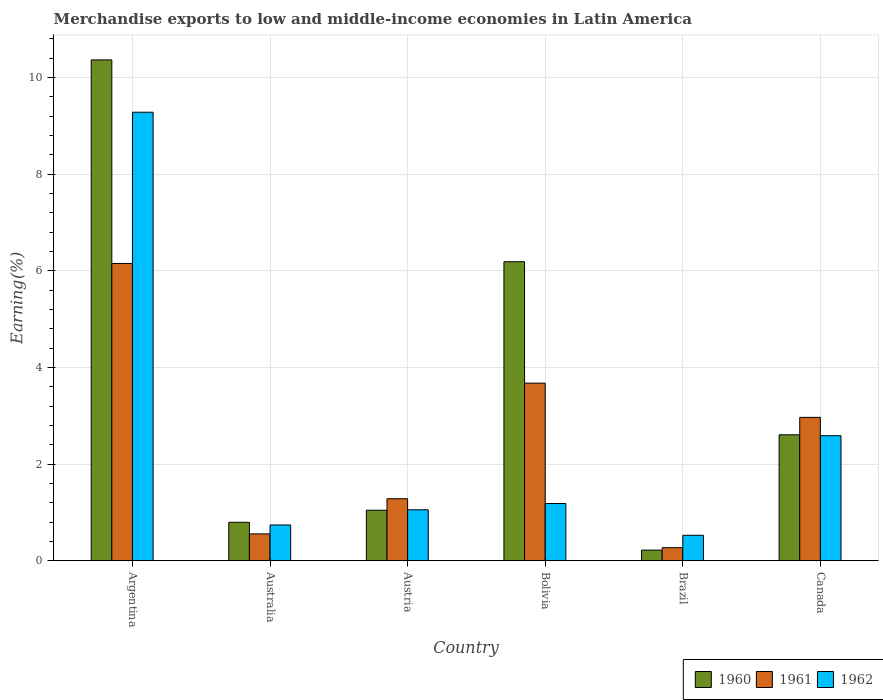How many different coloured bars are there?
Give a very brief answer. 3. What is the percentage of amount earned from merchandise exports in 1962 in Bolivia?
Your answer should be compact. 1.18. Across all countries, what is the maximum percentage of amount earned from merchandise exports in 1960?
Your answer should be very brief. 10.36. Across all countries, what is the minimum percentage of amount earned from merchandise exports in 1962?
Make the answer very short. 0.53. What is the total percentage of amount earned from merchandise exports in 1960 in the graph?
Offer a terse response. 21.21. What is the difference between the percentage of amount earned from merchandise exports in 1961 in Australia and that in Brazil?
Ensure brevity in your answer.  0.28. What is the difference between the percentage of amount earned from merchandise exports in 1961 in Canada and the percentage of amount earned from merchandise exports in 1960 in Austria?
Make the answer very short. 1.92. What is the average percentage of amount earned from merchandise exports in 1962 per country?
Your response must be concise. 2.56. What is the difference between the percentage of amount earned from merchandise exports of/in 1960 and percentage of amount earned from merchandise exports of/in 1962 in Australia?
Your response must be concise. 0.06. In how many countries, is the percentage of amount earned from merchandise exports in 1961 greater than 5.2 %?
Your answer should be compact. 1. What is the ratio of the percentage of amount earned from merchandise exports in 1961 in Austria to that in Brazil?
Give a very brief answer. 4.74. Is the percentage of amount earned from merchandise exports in 1961 in Austria less than that in Bolivia?
Your answer should be compact. Yes. What is the difference between the highest and the second highest percentage of amount earned from merchandise exports in 1961?
Your answer should be very brief. -0.71. What is the difference between the highest and the lowest percentage of amount earned from merchandise exports in 1962?
Provide a short and direct response. 8.75. How many bars are there?
Provide a succinct answer. 18. Does the graph contain grids?
Offer a very short reply. Yes. What is the title of the graph?
Provide a short and direct response. Merchandise exports to low and middle-income economies in Latin America. Does "1964" appear as one of the legend labels in the graph?
Provide a short and direct response. No. What is the label or title of the X-axis?
Your response must be concise. Country. What is the label or title of the Y-axis?
Your response must be concise. Earning(%). What is the Earning(%) of 1960 in Argentina?
Your response must be concise. 10.36. What is the Earning(%) of 1961 in Argentina?
Make the answer very short. 6.15. What is the Earning(%) in 1962 in Argentina?
Your response must be concise. 9.28. What is the Earning(%) of 1960 in Australia?
Give a very brief answer. 0.8. What is the Earning(%) in 1961 in Australia?
Ensure brevity in your answer.  0.56. What is the Earning(%) in 1962 in Australia?
Your answer should be very brief. 0.74. What is the Earning(%) in 1960 in Austria?
Your response must be concise. 1.05. What is the Earning(%) of 1961 in Austria?
Provide a succinct answer. 1.28. What is the Earning(%) in 1962 in Austria?
Give a very brief answer. 1.05. What is the Earning(%) of 1960 in Bolivia?
Keep it short and to the point. 6.19. What is the Earning(%) of 1961 in Bolivia?
Provide a short and direct response. 3.67. What is the Earning(%) of 1962 in Bolivia?
Provide a short and direct response. 1.18. What is the Earning(%) of 1960 in Brazil?
Your response must be concise. 0.22. What is the Earning(%) in 1961 in Brazil?
Give a very brief answer. 0.27. What is the Earning(%) of 1962 in Brazil?
Offer a very short reply. 0.53. What is the Earning(%) in 1960 in Canada?
Your response must be concise. 2.61. What is the Earning(%) of 1961 in Canada?
Provide a succinct answer. 2.97. What is the Earning(%) in 1962 in Canada?
Provide a succinct answer. 2.59. Across all countries, what is the maximum Earning(%) in 1960?
Keep it short and to the point. 10.36. Across all countries, what is the maximum Earning(%) in 1961?
Offer a very short reply. 6.15. Across all countries, what is the maximum Earning(%) of 1962?
Offer a terse response. 9.28. Across all countries, what is the minimum Earning(%) of 1960?
Your answer should be compact. 0.22. Across all countries, what is the minimum Earning(%) of 1961?
Provide a short and direct response. 0.27. Across all countries, what is the minimum Earning(%) in 1962?
Provide a short and direct response. 0.53. What is the total Earning(%) in 1960 in the graph?
Your answer should be compact. 21.21. What is the total Earning(%) of 1961 in the graph?
Your answer should be very brief. 14.9. What is the total Earning(%) of 1962 in the graph?
Keep it short and to the point. 15.37. What is the difference between the Earning(%) of 1960 in Argentina and that in Australia?
Give a very brief answer. 9.56. What is the difference between the Earning(%) of 1961 in Argentina and that in Australia?
Your response must be concise. 5.59. What is the difference between the Earning(%) of 1962 in Argentina and that in Australia?
Ensure brevity in your answer.  8.54. What is the difference between the Earning(%) of 1960 in Argentina and that in Austria?
Offer a very short reply. 9.31. What is the difference between the Earning(%) of 1961 in Argentina and that in Austria?
Keep it short and to the point. 4.87. What is the difference between the Earning(%) in 1962 in Argentina and that in Austria?
Your answer should be very brief. 8.22. What is the difference between the Earning(%) in 1960 in Argentina and that in Bolivia?
Provide a succinct answer. 4.17. What is the difference between the Earning(%) in 1961 in Argentina and that in Bolivia?
Your answer should be very brief. 2.48. What is the difference between the Earning(%) of 1962 in Argentina and that in Bolivia?
Offer a terse response. 8.09. What is the difference between the Earning(%) in 1960 in Argentina and that in Brazil?
Your answer should be very brief. 10.14. What is the difference between the Earning(%) of 1961 in Argentina and that in Brazil?
Provide a succinct answer. 5.88. What is the difference between the Earning(%) of 1962 in Argentina and that in Brazil?
Ensure brevity in your answer.  8.75. What is the difference between the Earning(%) of 1960 in Argentina and that in Canada?
Make the answer very short. 7.75. What is the difference between the Earning(%) in 1961 in Argentina and that in Canada?
Your response must be concise. 3.18. What is the difference between the Earning(%) in 1962 in Argentina and that in Canada?
Your response must be concise. 6.69. What is the difference between the Earning(%) in 1960 in Australia and that in Austria?
Your response must be concise. -0.25. What is the difference between the Earning(%) in 1961 in Australia and that in Austria?
Offer a very short reply. -0.73. What is the difference between the Earning(%) of 1962 in Australia and that in Austria?
Your answer should be very brief. -0.31. What is the difference between the Earning(%) of 1960 in Australia and that in Bolivia?
Offer a terse response. -5.39. What is the difference between the Earning(%) of 1961 in Australia and that in Bolivia?
Give a very brief answer. -3.12. What is the difference between the Earning(%) in 1962 in Australia and that in Bolivia?
Your answer should be very brief. -0.44. What is the difference between the Earning(%) in 1960 in Australia and that in Brazil?
Your answer should be compact. 0.58. What is the difference between the Earning(%) in 1961 in Australia and that in Brazil?
Your answer should be very brief. 0.28. What is the difference between the Earning(%) of 1962 in Australia and that in Brazil?
Provide a short and direct response. 0.21. What is the difference between the Earning(%) of 1960 in Australia and that in Canada?
Keep it short and to the point. -1.81. What is the difference between the Earning(%) of 1961 in Australia and that in Canada?
Your response must be concise. -2.41. What is the difference between the Earning(%) of 1962 in Australia and that in Canada?
Ensure brevity in your answer.  -1.85. What is the difference between the Earning(%) in 1960 in Austria and that in Bolivia?
Offer a very short reply. -5.14. What is the difference between the Earning(%) in 1961 in Austria and that in Bolivia?
Offer a very short reply. -2.39. What is the difference between the Earning(%) in 1962 in Austria and that in Bolivia?
Your response must be concise. -0.13. What is the difference between the Earning(%) in 1960 in Austria and that in Brazil?
Offer a terse response. 0.83. What is the difference between the Earning(%) of 1961 in Austria and that in Brazil?
Provide a short and direct response. 1.01. What is the difference between the Earning(%) of 1962 in Austria and that in Brazil?
Provide a succinct answer. 0.53. What is the difference between the Earning(%) of 1960 in Austria and that in Canada?
Your response must be concise. -1.56. What is the difference between the Earning(%) of 1961 in Austria and that in Canada?
Offer a very short reply. -1.68. What is the difference between the Earning(%) in 1962 in Austria and that in Canada?
Your answer should be very brief. -1.53. What is the difference between the Earning(%) of 1960 in Bolivia and that in Brazil?
Ensure brevity in your answer.  5.97. What is the difference between the Earning(%) of 1961 in Bolivia and that in Brazil?
Provide a succinct answer. 3.4. What is the difference between the Earning(%) in 1962 in Bolivia and that in Brazil?
Ensure brevity in your answer.  0.66. What is the difference between the Earning(%) in 1960 in Bolivia and that in Canada?
Provide a succinct answer. 3.58. What is the difference between the Earning(%) in 1961 in Bolivia and that in Canada?
Offer a very short reply. 0.71. What is the difference between the Earning(%) in 1962 in Bolivia and that in Canada?
Provide a short and direct response. -1.4. What is the difference between the Earning(%) of 1960 in Brazil and that in Canada?
Your response must be concise. -2.39. What is the difference between the Earning(%) in 1961 in Brazil and that in Canada?
Give a very brief answer. -2.7. What is the difference between the Earning(%) of 1962 in Brazil and that in Canada?
Ensure brevity in your answer.  -2.06. What is the difference between the Earning(%) in 1960 in Argentina and the Earning(%) in 1961 in Australia?
Give a very brief answer. 9.8. What is the difference between the Earning(%) in 1960 in Argentina and the Earning(%) in 1962 in Australia?
Ensure brevity in your answer.  9.62. What is the difference between the Earning(%) of 1961 in Argentina and the Earning(%) of 1962 in Australia?
Offer a very short reply. 5.41. What is the difference between the Earning(%) of 1960 in Argentina and the Earning(%) of 1961 in Austria?
Provide a short and direct response. 9.08. What is the difference between the Earning(%) of 1960 in Argentina and the Earning(%) of 1962 in Austria?
Your answer should be very brief. 9.31. What is the difference between the Earning(%) of 1961 in Argentina and the Earning(%) of 1962 in Austria?
Your answer should be very brief. 5.1. What is the difference between the Earning(%) of 1960 in Argentina and the Earning(%) of 1961 in Bolivia?
Offer a very short reply. 6.69. What is the difference between the Earning(%) of 1960 in Argentina and the Earning(%) of 1962 in Bolivia?
Your answer should be very brief. 9.18. What is the difference between the Earning(%) in 1961 in Argentina and the Earning(%) in 1962 in Bolivia?
Give a very brief answer. 4.97. What is the difference between the Earning(%) in 1960 in Argentina and the Earning(%) in 1961 in Brazil?
Ensure brevity in your answer.  10.09. What is the difference between the Earning(%) of 1960 in Argentina and the Earning(%) of 1962 in Brazil?
Offer a terse response. 9.83. What is the difference between the Earning(%) of 1961 in Argentina and the Earning(%) of 1962 in Brazil?
Offer a terse response. 5.62. What is the difference between the Earning(%) of 1960 in Argentina and the Earning(%) of 1961 in Canada?
Your response must be concise. 7.39. What is the difference between the Earning(%) in 1960 in Argentina and the Earning(%) in 1962 in Canada?
Provide a succinct answer. 7.77. What is the difference between the Earning(%) in 1961 in Argentina and the Earning(%) in 1962 in Canada?
Give a very brief answer. 3.56. What is the difference between the Earning(%) in 1960 in Australia and the Earning(%) in 1961 in Austria?
Ensure brevity in your answer.  -0.49. What is the difference between the Earning(%) in 1960 in Australia and the Earning(%) in 1962 in Austria?
Ensure brevity in your answer.  -0.26. What is the difference between the Earning(%) of 1961 in Australia and the Earning(%) of 1962 in Austria?
Provide a short and direct response. -0.5. What is the difference between the Earning(%) of 1960 in Australia and the Earning(%) of 1961 in Bolivia?
Offer a terse response. -2.88. What is the difference between the Earning(%) in 1960 in Australia and the Earning(%) in 1962 in Bolivia?
Your response must be concise. -0.39. What is the difference between the Earning(%) of 1961 in Australia and the Earning(%) of 1962 in Bolivia?
Your answer should be compact. -0.63. What is the difference between the Earning(%) in 1960 in Australia and the Earning(%) in 1961 in Brazil?
Give a very brief answer. 0.52. What is the difference between the Earning(%) in 1960 in Australia and the Earning(%) in 1962 in Brazil?
Make the answer very short. 0.27. What is the difference between the Earning(%) of 1961 in Australia and the Earning(%) of 1962 in Brazil?
Make the answer very short. 0.03. What is the difference between the Earning(%) in 1960 in Australia and the Earning(%) in 1961 in Canada?
Offer a very short reply. -2.17. What is the difference between the Earning(%) in 1960 in Australia and the Earning(%) in 1962 in Canada?
Provide a succinct answer. -1.79. What is the difference between the Earning(%) of 1961 in Australia and the Earning(%) of 1962 in Canada?
Your answer should be compact. -2.03. What is the difference between the Earning(%) of 1960 in Austria and the Earning(%) of 1961 in Bolivia?
Your answer should be compact. -2.63. What is the difference between the Earning(%) of 1960 in Austria and the Earning(%) of 1962 in Bolivia?
Offer a terse response. -0.14. What is the difference between the Earning(%) of 1961 in Austria and the Earning(%) of 1962 in Bolivia?
Offer a terse response. 0.1. What is the difference between the Earning(%) of 1960 in Austria and the Earning(%) of 1961 in Brazil?
Provide a short and direct response. 0.77. What is the difference between the Earning(%) of 1960 in Austria and the Earning(%) of 1962 in Brazil?
Give a very brief answer. 0.52. What is the difference between the Earning(%) of 1961 in Austria and the Earning(%) of 1962 in Brazil?
Make the answer very short. 0.76. What is the difference between the Earning(%) in 1960 in Austria and the Earning(%) in 1961 in Canada?
Provide a short and direct response. -1.92. What is the difference between the Earning(%) of 1960 in Austria and the Earning(%) of 1962 in Canada?
Your answer should be compact. -1.54. What is the difference between the Earning(%) in 1961 in Austria and the Earning(%) in 1962 in Canada?
Make the answer very short. -1.3. What is the difference between the Earning(%) of 1960 in Bolivia and the Earning(%) of 1961 in Brazil?
Offer a very short reply. 5.91. What is the difference between the Earning(%) of 1960 in Bolivia and the Earning(%) of 1962 in Brazil?
Your answer should be compact. 5.66. What is the difference between the Earning(%) in 1961 in Bolivia and the Earning(%) in 1962 in Brazil?
Provide a succinct answer. 3.15. What is the difference between the Earning(%) of 1960 in Bolivia and the Earning(%) of 1961 in Canada?
Your answer should be very brief. 3.22. What is the difference between the Earning(%) of 1960 in Bolivia and the Earning(%) of 1962 in Canada?
Your answer should be very brief. 3.6. What is the difference between the Earning(%) in 1961 in Bolivia and the Earning(%) in 1962 in Canada?
Provide a short and direct response. 1.09. What is the difference between the Earning(%) in 1960 in Brazil and the Earning(%) in 1961 in Canada?
Your answer should be compact. -2.75. What is the difference between the Earning(%) of 1960 in Brazil and the Earning(%) of 1962 in Canada?
Provide a short and direct response. -2.37. What is the difference between the Earning(%) in 1961 in Brazil and the Earning(%) in 1962 in Canada?
Ensure brevity in your answer.  -2.32. What is the average Earning(%) in 1960 per country?
Your answer should be very brief. 3.54. What is the average Earning(%) in 1961 per country?
Offer a terse response. 2.48. What is the average Earning(%) in 1962 per country?
Your answer should be compact. 2.56. What is the difference between the Earning(%) in 1960 and Earning(%) in 1961 in Argentina?
Keep it short and to the point. 4.21. What is the difference between the Earning(%) in 1960 and Earning(%) in 1962 in Argentina?
Keep it short and to the point. 1.08. What is the difference between the Earning(%) of 1961 and Earning(%) of 1962 in Argentina?
Keep it short and to the point. -3.13. What is the difference between the Earning(%) in 1960 and Earning(%) in 1961 in Australia?
Give a very brief answer. 0.24. What is the difference between the Earning(%) of 1960 and Earning(%) of 1962 in Australia?
Give a very brief answer. 0.06. What is the difference between the Earning(%) of 1961 and Earning(%) of 1962 in Australia?
Keep it short and to the point. -0.18. What is the difference between the Earning(%) in 1960 and Earning(%) in 1961 in Austria?
Your answer should be very brief. -0.24. What is the difference between the Earning(%) of 1960 and Earning(%) of 1962 in Austria?
Ensure brevity in your answer.  -0.01. What is the difference between the Earning(%) of 1961 and Earning(%) of 1962 in Austria?
Offer a terse response. 0.23. What is the difference between the Earning(%) in 1960 and Earning(%) in 1961 in Bolivia?
Make the answer very short. 2.51. What is the difference between the Earning(%) of 1960 and Earning(%) of 1962 in Bolivia?
Your response must be concise. 5. What is the difference between the Earning(%) of 1961 and Earning(%) of 1962 in Bolivia?
Keep it short and to the point. 2.49. What is the difference between the Earning(%) in 1960 and Earning(%) in 1961 in Brazil?
Keep it short and to the point. -0.05. What is the difference between the Earning(%) in 1960 and Earning(%) in 1962 in Brazil?
Provide a short and direct response. -0.31. What is the difference between the Earning(%) of 1961 and Earning(%) of 1962 in Brazil?
Ensure brevity in your answer.  -0.26. What is the difference between the Earning(%) of 1960 and Earning(%) of 1961 in Canada?
Provide a short and direct response. -0.36. What is the difference between the Earning(%) of 1960 and Earning(%) of 1962 in Canada?
Your answer should be compact. 0.02. What is the difference between the Earning(%) of 1961 and Earning(%) of 1962 in Canada?
Provide a short and direct response. 0.38. What is the ratio of the Earning(%) in 1960 in Argentina to that in Australia?
Provide a short and direct response. 13.02. What is the ratio of the Earning(%) of 1961 in Argentina to that in Australia?
Your answer should be very brief. 11.06. What is the ratio of the Earning(%) in 1962 in Argentina to that in Australia?
Give a very brief answer. 12.53. What is the ratio of the Earning(%) in 1960 in Argentina to that in Austria?
Offer a terse response. 9.91. What is the ratio of the Earning(%) in 1961 in Argentina to that in Austria?
Keep it short and to the point. 4.79. What is the ratio of the Earning(%) in 1962 in Argentina to that in Austria?
Give a very brief answer. 8.8. What is the ratio of the Earning(%) in 1960 in Argentina to that in Bolivia?
Provide a short and direct response. 1.67. What is the ratio of the Earning(%) of 1961 in Argentina to that in Bolivia?
Provide a succinct answer. 1.67. What is the ratio of the Earning(%) in 1962 in Argentina to that in Bolivia?
Keep it short and to the point. 7.84. What is the ratio of the Earning(%) in 1960 in Argentina to that in Brazil?
Ensure brevity in your answer.  46.99. What is the ratio of the Earning(%) of 1961 in Argentina to that in Brazil?
Provide a succinct answer. 22.7. What is the ratio of the Earning(%) in 1962 in Argentina to that in Brazil?
Make the answer very short. 17.59. What is the ratio of the Earning(%) of 1960 in Argentina to that in Canada?
Provide a short and direct response. 3.98. What is the ratio of the Earning(%) in 1961 in Argentina to that in Canada?
Keep it short and to the point. 2.07. What is the ratio of the Earning(%) of 1962 in Argentina to that in Canada?
Make the answer very short. 3.59. What is the ratio of the Earning(%) in 1960 in Australia to that in Austria?
Keep it short and to the point. 0.76. What is the ratio of the Earning(%) in 1961 in Australia to that in Austria?
Your response must be concise. 0.43. What is the ratio of the Earning(%) in 1962 in Australia to that in Austria?
Keep it short and to the point. 0.7. What is the ratio of the Earning(%) in 1960 in Australia to that in Bolivia?
Ensure brevity in your answer.  0.13. What is the ratio of the Earning(%) of 1961 in Australia to that in Bolivia?
Keep it short and to the point. 0.15. What is the ratio of the Earning(%) of 1962 in Australia to that in Bolivia?
Offer a very short reply. 0.63. What is the ratio of the Earning(%) in 1960 in Australia to that in Brazil?
Provide a short and direct response. 3.61. What is the ratio of the Earning(%) of 1961 in Australia to that in Brazil?
Your answer should be very brief. 2.05. What is the ratio of the Earning(%) of 1962 in Australia to that in Brazil?
Keep it short and to the point. 1.4. What is the ratio of the Earning(%) in 1960 in Australia to that in Canada?
Provide a short and direct response. 0.31. What is the ratio of the Earning(%) of 1961 in Australia to that in Canada?
Your response must be concise. 0.19. What is the ratio of the Earning(%) of 1962 in Australia to that in Canada?
Give a very brief answer. 0.29. What is the ratio of the Earning(%) in 1960 in Austria to that in Bolivia?
Your answer should be compact. 0.17. What is the ratio of the Earning(%) in 1961 in Austria to that in Bolivia?
Ensure brevity in your answer.  0.35. What is the ratio of the Earning(%) of 1962 in Austria to that in Bolivia?
Offer a very short reply. 0.89. What is the ratio of the Earning(%) of 1960 in Austria to that in Brazil?
Ensure brevity in your answer.  4.74. What is the ratio of the Earning(%) in 1961 in Austria to that in Brazil?
Your answer should be compact. 4.74. What is the ratio of the Earning(%) of 1962 in Austria to that in Brazil?
Your answer should be very brief. 2. What is the ratio of the Earning(%) of 1960 in Austria to that in Canada?
Offer a very short reply. 0.4. What is the ratio of the Earning(%) of 1961 in Austria to that in Canada?
Offer a very short reply. 0.43. What is the ratio of the Earning(%) in 1962 in Austria to that in Canada?
Your answer should be very brief. 0.41. What is the ratio of the Earning(%) in 1960 in Bolivia to that in Brazil?
Ensure brevity in your answer.  28.05. What is the ratio of the Earning(%) in 1961 in Bolivia to that in Brazil?
Ensure brevity in your answer.  13.56. What is the ratio of the Earning(%) in 1962 in Bolivia to that in Brazil?
Keep it short and to the point. 2.25. What is the ratio of the Earning(%) of 1960 in Bolivia to that in Canada?
Your response must be concise. 2.37. What is the ratio of the Earning(%) of 1961 in Bolivia to that in Canada?
Your response must be concise. 1.24. What is the ratio of the Earning(%) in 1962 in Bolivia to that in Canada?
Make the answer very short. 0.46. What is the ratio of the Earning(%) in 1960 in Brazil to that in Canada?
Give a very brief answer. 0.08. What is the ratio of the Earning(%) in 1961 in Brazil to that in Canada?
Offer a very short reply. 0.09. What is the ratio of the Earning(%) in 1962 in Brazil to that in Canada?
Offer a terse response. 0.2. What is the difference between the highest and the second highest Earning(%) in 1960?
Provide a succinct answer. 4.17. What is the difference between the highest and the second highest Earning(%) in 1961?
Give a very brief answer. 2.48. What is the difference between the highest and the second highest Earning(%) of 1962?
Your answer should be very brief. 6.69. What is the difference between the highest and the lowest Earning(%) in 1960?
Your answer should be compact. 10.14. What is the difference between the highest and the lowest Earning(%) in 1961?
Ensure brevity in your answer.  5.88. What is the difference between the highest and the lowest Earning(%) of 1962?
Offer a very short reply. 8.75. 